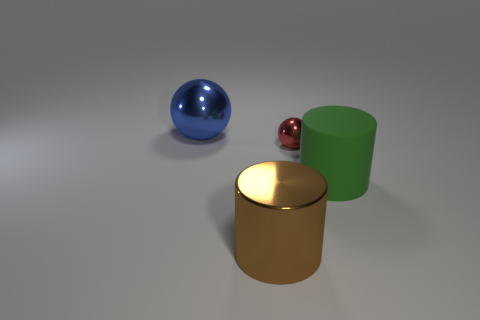There is a large shiny thing in front of the tiny shiny sphere; is its shape the same as the small red object that is in front of the large metallic ball?
Your answer should be very brief. No. Are there any other blue balls made of the same material as the blue ball?
Keep it short and to the point. No. What number of brown things are either spheres or big things?
Offer a very short reply. 1. What is the size of the object that is in front of the tiny object and on the left side of the large rubber thing?
Offer a very short reply. Large. Are there more small balls that are left of the matte cylinder than large yellow blocks?
Offer a very short reply. Yes. What number of balls are big brown metallic objects or big metallic objects?
Give a very brief answer. 1. What shape is the large object that is left of the rubber cylinder and on the right side of the blue shiny ball?
Your answer should be compact. Cylinder. Is the number of big shiny cylinders that are to the right of the big rubber thing the same as the number of brown metallic things that are to the right of the red ball?
Offer a very short reply. Yes. What number of objects are either large blue spheres or large green balls?
Ensure brevity in your answer.  1. The cylinder that is the same size as the matte thing is what color?
Your response must be concise. Brown. 